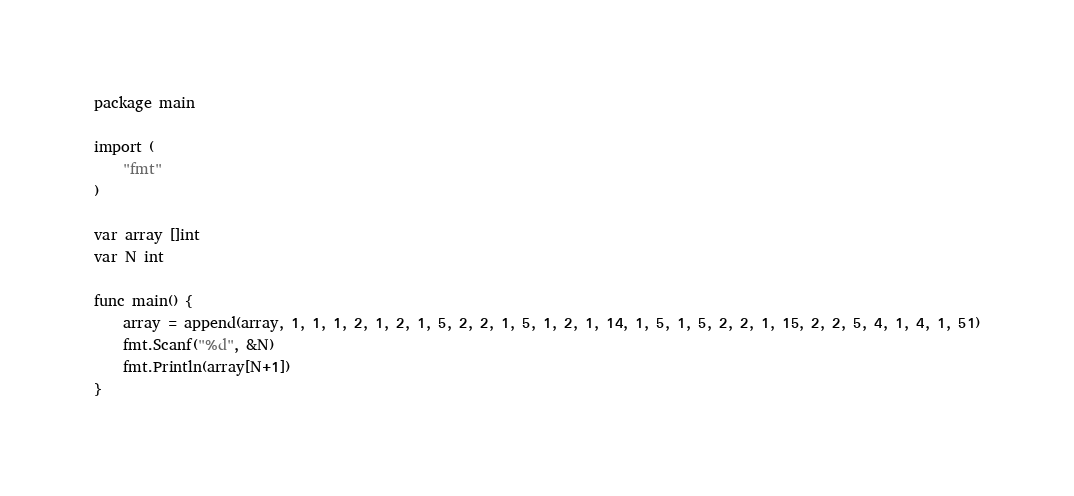Convert code to text. <code><loc_0><loc_0><loc_500><loc_500><_Go_>package main

import (
	"fmt"
)

var array []int
var N int

func main() {
	array = append(array, 1, 1, 1, 2, 1, 2, 1, 5, 2, 2, 1, 5, 1, 2, 1, 14, 1, 5, 1, 5, 2, 2, 1, 15, 2, 2, 5, 4, 1, 4, 1, 51)
	fmt.Scanf("%d", &N)
	fmt.Println(array[N+1])
}
</code> 